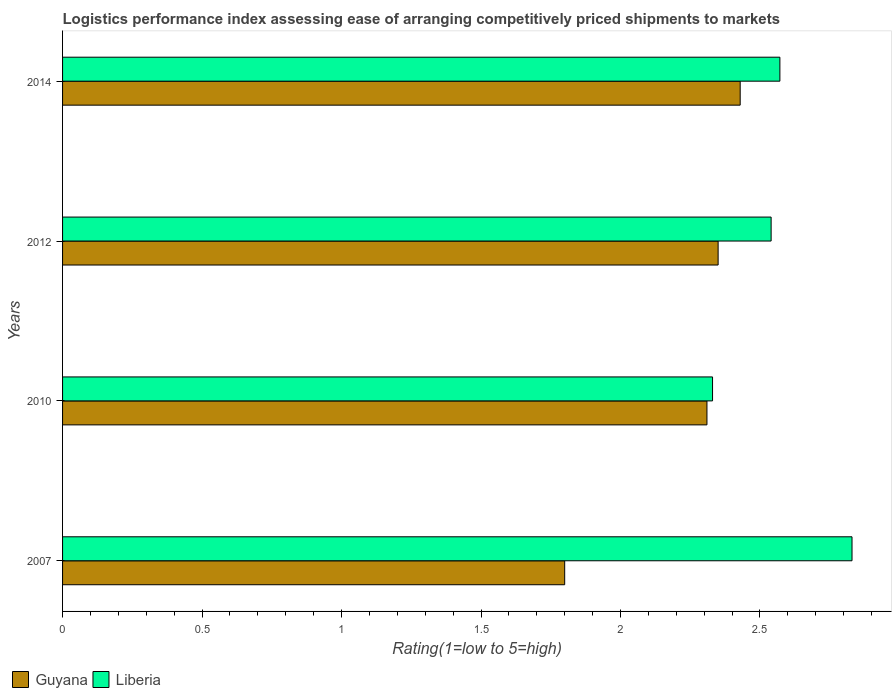How many different coloured bars are there?
Your response must be concise. 2. How many groups of bars are there?
Provide a short and direct response. 4. Are the number of bars per tick equal to the number of legend labels?
Your answer should be compact. Yes. Are the number of bars on each tick of the Y-axis equal?
Make the answer very short. Yes. How many bars are there on the 2nd tick from the top?
Your response must be concise. 2. How many bars are there on the 2nd tick from the bottom?
Keep it short and to the point. 2. In how many cases, is the number of bars for a given year not equal to the number of legend labels?
Provide a succinct answer. 0. What is the Logistic performance index in Guyana in 2010?
Ensure brevity in your answer.  2.31. Across all years, what is the maximum Logistic performance index in Liberia?
Provide a succinct answer. 2.83. Across all years, what is the minimum Logistic performance index in Liberia?
Ensure brevity in your answer.  2.33. In which year was the Logistic performance index in Liberia minimum?
Offer a very short reply. 2010. What is the total Logistic performance index in Liberia in the graph?
Offer a very short reply. 10.27. What is the difference between the Logistic performance index in Liberia in 2010 and that in 2014?
Your answer should be compact. -0.24. What is the difference between the Logistic performance index in Liberia in 2010 and the Logistic performance index in Guyana in 2012?
Your answer should be compact. -0.02. What is the average Logistic performance index in Guyana per year?
Keep it short and to the point. 2.22. In the year 2007, what is the difference between the Logistic performance index in Liberia and Logistic performance index in Guyana?
Offer a very short reply. 1.03. What is the ratio of the Logistic performance index in Guyana in 2007 to that in 2010?
Your response must be concise. 0.78. Is the difference between the Logistic performance index in Liberia in 2010 and 2014 greater than the difference between the Logistic performance index in Guyana in 2010 and 2014?
Offer a very short reply. No. What is the difference between the highest and the second highest Logistic performance index in Liberia?
Your answer should be very brief. 0.26. What is the difference between the highest and the lowest Logistic performance index in Liberia?
Offer a very short reply. 0.5. Is the sum of the Logistic performance index in Guyana in 2010 and 2014 greater than the maximum Logistic performance index in Liberia across all years?
Keep it short and to the point. Yes. What does the 2nd bar from the top in 2014 represents?
Provide a short and direct response. Guyana. What does the 1st bar from the bottom in 2014 represents?
Give a very brief answer. Guyana. How many bars are there?
Your response must be concise. 8. Are all the bars in the graph horizontal?
Your response must be concise. Yes. Are the values on the major ticks of X-axis written in scientific E-notation?
Make the answer very short. No. Does the graph contain any zero values?
Provide a short and direct response. No. Does the graph contain grids?
Ensure brevity in your answer.  No. Where does the legend appear in the graph?
Your answer should be very brief. Bottom left. How many legend labels are there?
Your response must be concise. 2. What is the title of the graph?
Make the answer very short. Logistics performance index assessing ease of arranging competitively priced shipments to markets. What is the label or title of the X-axis?
Your response must be concise. Rating(1=low to 5=high). What is the Rating(1=low to 5=high) in Guyana in 2007?
Provide a succinct answer. 1.8. What is the Rating(1=low to 5=high) in Liberia in 2007?
Keep it short and to the point. 2.83. What is the Rating(1=low to 5=high) of Guyana in 2010?
Provide a succinct answer. 2.31. What is the Rating(1=low to 5=high) of Liberia in 2010?
Offer a very short reply. 2.33. What is the Rating(1=low to 5=high) in Guyana in 2012?
Provide a succinct answer. 2.35. What is the Rating(1=low to 5=high) of Liberia in 2012?
Give a very brief answer. 2.54. What is the Rating(1=low to 5=high) of Guyana in 2014?
Offer a very short reply. 2.43. What is the Rating(1=low to 5=high) of Liberia in 2014?
Offer a very short reply. 2.57. Across all years, what is the maximum Rating(1=low to 5=high) in Guyana?
Provide a succinct answer. 2.43. Across all years, what is the maximum Rating(1=low to 5=high) in Liberia?
Your answer should be very brief. 2.83. Across all years, what is the minimum Rating(1=low to 5=high) of Guyana?
Ensure brevity in your answer.  1.8. Across all years, what is the minimum Rating(1=low to 5=high) in Liberia?
Give a very brief answer. 2.33. What is the total Rating(1=low to 5=high) of Guyana in the graph?
Your answer should be compact. 8.89. What is the total Rating(1=low to 5=high) of Liberia in the graph?
Make the answer very short. 10.27. What is the difference between the Rating(1=low to 5=high) in Guyana in 2007 and that in 2010?
Provide a succinct answer. -0.51. What is the difference between the Rating(1=low to 5=high) of Liberia in 2007 and that in 2010?
Keep it short and to the point. 0.5. What is the difference between the Rating(1=low to 5=high) of Guyana in 2007 and that in 2012?
Offer a terse response. -0.55. What is the difference between the Rating(1=low to 5=high) in Liberia in 2007 and that in 2012?
Offer a terse response. 0.29. What is the difference between the Rating(1=low to 5=high) of Guyana in 2007 and that in 2014?
Keep it short and to the point. -0.63. What is the difference between the Rating(1=low to 5=high) in Liberia in 2007 and that in 2014?
Your answer should be very brief. 0.26. What is the difference between the Rating(1=low to 5=high) in Guyana in 2010 and that in 2012?
Provide a short and direct response. -0.04. What is the difference between the Rating(1=low to 5=high) in Liberia in 2010 and that in 2012?
Give a very brief answer. -0.21. What is the difference between the Rating(1=low to 5=high) in Guyana in 2010 and that in 2014?
Offer a terse response. -0.12. What is the difference between the Rating(1=low to 5=high) of Liberia in 2010 and that in 2014?
Offer a very short reply. -0.24. What is the difference between the Rating(1=low to 5=high) in Guyana in 2012 and that in 2014?
Provide a short and direct response. -0.08. What is the difference between the Rating(1=low to 5=high) in Liberia in 2012 and that in 2014?
Offer a terse response. -0.03. What is the difference between the Rating(1=low to 5=high) of Guyana in 2007 and the Rating(1=low to 5=high) of Liberia in 2010?
Offer a terse response. -0.53. What is the difference between the Rating(1=low to 5=high) in Guyana in 2007 and the Rating(1=low to 5=high) in Liberia in 2012?
Your answer should be compact. -0.74. What is the difference between the Rating(1=low to 5=high) in Guyana in 2007 and the Rating(1=low to 5=high) in Liberia in 2014?
Your response must be concise. -0.77. What is the difference between the Rating(1=low to 5=high) in Guyana in 2010 and the Rating(1=low to 5=high) in Liberia in 2012?
Make the answer very short. -0.23. What is the difference between the Rating(1=low to 5=high) of Guyana in 2010 and the Rating(1=low to 5=high) of Liberia in 2014?
Your answer should be very brief. -0.26. What is the difference between the Rating(1=low to 5=high) of Guyana in 2012 and the Rating(1=low to 5=high) of Liberia in 2014?
Your answer should be very brief. -0.22. What is the average Rating(1=low to 5=high) in Guyana per year?
Ensure brevity in your answer.  2.22. What is the average Rating(1=low to 5=high) in Liberia per year?
Give a very brief answer. 2.57. In the year 2007, what is the difference between the Rating(1=low to 5=high) in Guyana and Rating(1=low to 5=high) in Liberia?
Keep it short and to the point. -1.03. In the year 2010, what is the difference between the Rating(1=low to 5=high) of Guyana and Rating(1=low to 5=high) of Liberia?
Your answer should be very brief. -0.02. In the year 2012, what is the difference between the Rating(1=low to 5=high) of Guyana and Rating(1=low to 5=high) of Liberia?
Offer a very short reply. -0.19. In the year 2014, what is the difference between the Rating(1=low to 5=high) of Guyana and Rating(1=low to 5=high) of Liberia?
Keep it short and to the point. -0.14. What is the ratio of the Rating(1=low to 5=high) in Guyana in 2007 to that in 2010?
Give a very brief answer. 0.78. What is the ratio of the Rating(1=low to 5=high) of Liberia in 2007 to that in 2010?
Your answer should be very brief. 1.21. What is the ratio of the Rating(1=low to 5=high) in Guyana in 2007 to that in 2012?
Provide a short and direct response. 0.77. What is the ratio of the Rating(1=low to 5=high) in Liberia in 2007 to that in 2012?
Offer a very short reply. 1.11. What is the ratio of the Rating(1=low to 5=high) in Guyana in 2007 to that in 2014?
Offer a terse response. 0.74. What is the ratio of the Rating(1=low to 5=high) in Liberia in 2007 to that in 2014?
Your answer should be compact. 1.1. What is the ratio of the Rating(1=low to 5=high) in Guyana in 2010 to that in 2012?
Give a very brief answer. 0.98. What is the ratio of the Rating(1=low to 5=high) in Liberia in 2010 to that in 2012?
Give a very brief answer. 0.92. What is the ratio of the Rating(1=low to 5=high) of Guyana in 2010 to that in 2014?
Keep it short and to the point. 0.95. What is the ratio of the Rating(1=low to 5=high) of Liberia in 2010 to that in 2014?
Your answer should be very brief. 0.91. What is the ratio of the Rating(1=low to 5=high) of Guyana in 2012 to that in 2014?
Provide a short and direct response. 0.97. What is the difference between the highest and the second highest Rating(1=low to 5=high) in Guyana?
Offer a terse response. 0.08. What is the difference between the highest and the second highest Rating(1=low to 5=high) in Liberia?
Offer a very short reply. 0.26. What is the difference between the highest and the lowest Rating(1=low to 5=high) in Guyana?
Keep it short and to the point. 0.63. 